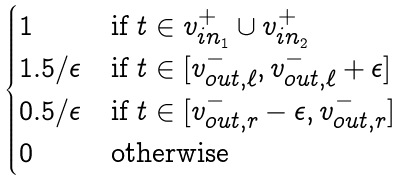<formula> <loc_0><loc_0><loc_500><loc_500>\begin{cases} 1 & \text {if } t \in v _ { i n _ { 1 } } ^ { + } \cup v _ { i n _ { 2 } } ^ { + } \\ 1 . 5 / \epsilon & \text {if } t \in [ v _ { o u t , \ell } ^ { - } , v _ { o u t , \ell } ^ { - } + \epsilon ] \\ 0 . 5 / \epsilon & \text {if } t \in [ v _ { o u t , r } ^ { - } - \epsilon , v _ { o u t , r } ^ { - } ] \\ 0 & \text {otherwise} \end{cases}</formula> 